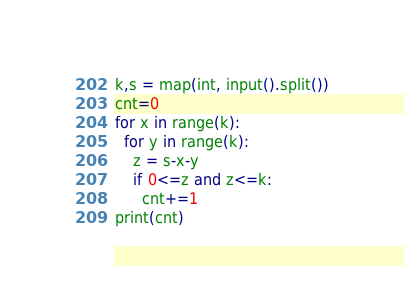<code> <loc_0><loc_0><loc_500><loc_500><_Python_>k,s = map(int, input().split())
cnt=0
for x in range(k):
  for y in range(k):
    z = s-x-y
    if 0<=z and z<=k:
      cnt+=1
print(cnt)
</code> 